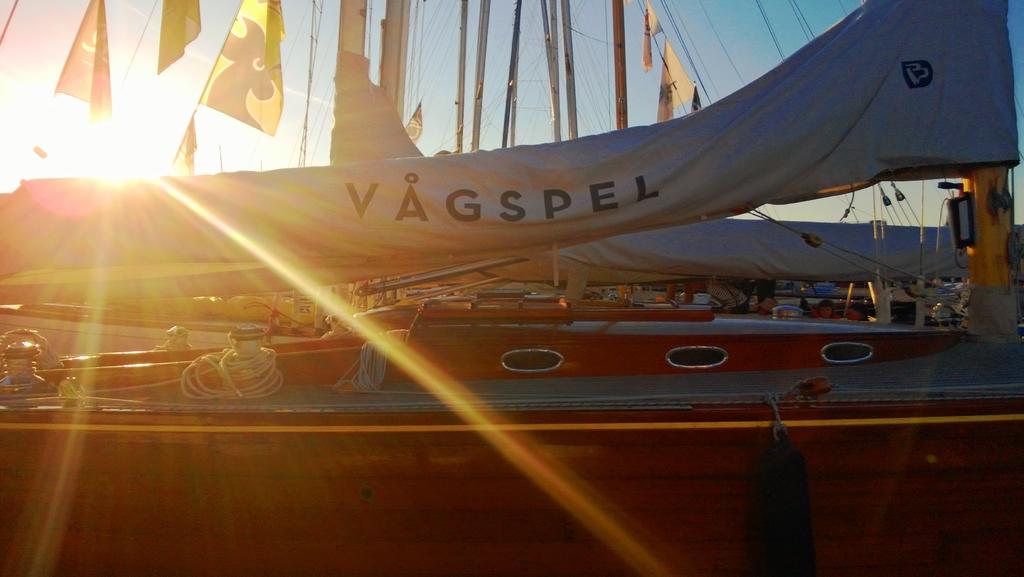What does the sail say?
Keep it short and to the point. Vagspel. 